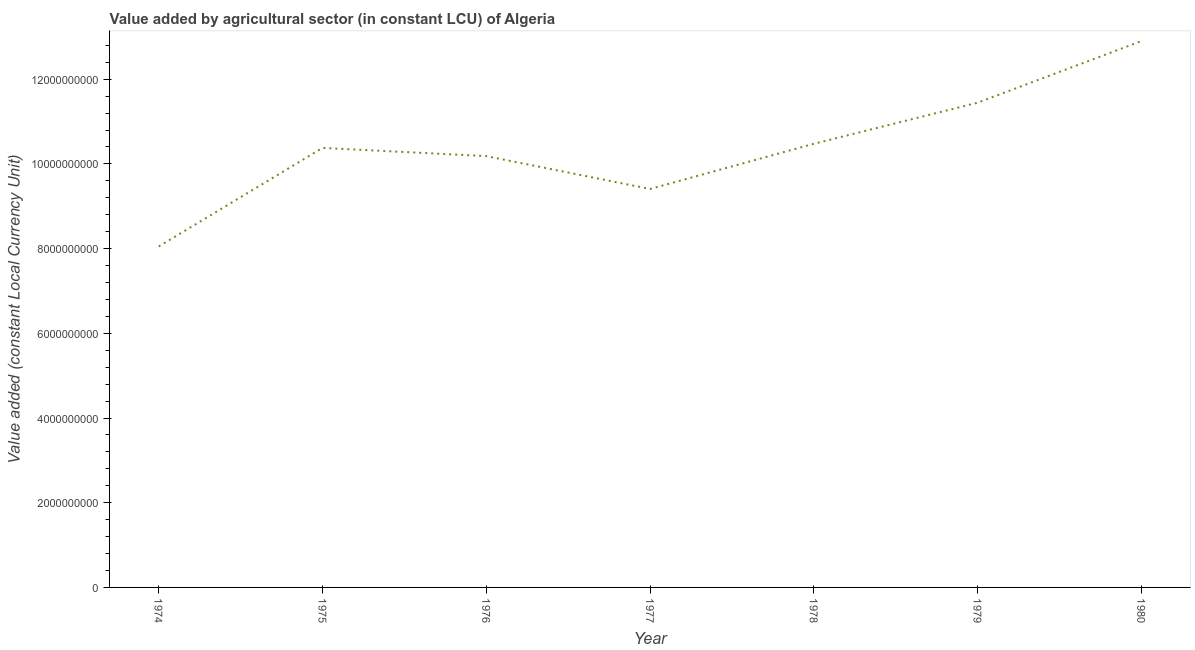What is the value added by agriculture sector in 1977?
Give a very brief answer. 9.41e+09. Across all years, what is the maximum value added by agriculture sector?
Provide a succinct answer. 1.29e+1. Across all years, what is the minimum value added by agriculture sector?
Keep it short and to the point. 8.05e+09. In which year was the value added by agriculture sector minimum?
Ensure brevity in your answer.  1974. What is the sum of the value added by agriculture sector?
Offer a very short reply. 7.28e+1. What is the difference between the value added by agriculture sector in 1976 and 1980?
Provide a short and direct response. -2.72e+09. What is the average value added by agriculture sector per year?
Give a very brief answer. 1.04e+1. What is the median value added by agriculture sector?
Keep it short and to the point. 1.04e+1. In how many years, is the value added by agriculture sector greater than 8400000000 LCU?
Offer a terse response. 6. What is the ratio of the value added by agriculture sector in 1976 to that in 1979?
Keep it short and to the point. 0.89. What is the difference between the highest and the second highest value added by agriculture sector?
Ensure brevity in your answer.  1.45e+09. What is the difference between the highest and the lowest value added by agriculture sector?
Ensure brevity in your answer.  4.85e+09. How many lines are there?
Your response must be concise. 1. What is the difference between two consecutive major ticks on the Y-axis?
Provide a succinct answer. 2.00e+09. Are the values on the major ticks of Y-axis written in scientific E-notation?
Keep it short and to the point. No. Does the graph contain any zero values?
Make the answer very short. No. Does the graph contain grids?
Ensure brevity in your answer.  No. What is the title of the graph?
Provide a succinct answer. Value added by agricultural sector (in constant LCU) of Algeria. What is the label or title of the Y-axis?
Your answer should be very brief. Value added (constant Local Currency Unit). What is the Value added (constant Local Currency Unit) of 1974?
Offer a very short reply. 8.05e+09. What is the Value added (constant Local Currency Unit) in 1975?
Offer a very short reply. 1.04e+1. What is the Value added (constant Local Currency Unit) of 1976?
Offer a terse response. 1.02e+1. What is the Value added (constant Local Currency Unit) of 1977?
Your response must be concise. 9.41e+09. What is the Value added (constant Local Currency Unit) of 1978?
Provide a succinct answer. 1.05e+1. What is the Value added (constant Local Currency Unit) in 1979?
Provide a short and direct response. 1.14e+1. What is the Value added (constant Local Currency Unit) of 1980?
Provide a short and direct response. 1.29e+1. What is the difference between the Value added (constant Local Currency Unit) in 1974 and 1975?
Provide a short and direct response. -2.33e+09. What is the difference between the Value added (constant Local Currency Unit) in 1974 and 1976?
Offer a terse response. -2.13e+09. What is the difference between the Value added (constant Local Currency Unit) in 1974 and 1977?
Ensure brevity in your answer.  -1.36e+09. What is the difference between the Value added (constant Local Currency Unit) in 1974 and 1978?
Offer a very short reply. -2.42e+09. What is the difference between the Value added (constant Local Currency Unit) in 1974 and 1979?
Your answer should be very brief. -3.39e+09. What is the difference between the Value added (constant Local Currency Unit) in 1974 and 1980?
Your response must be concise. -4.85e+09. What is the difference between the Value added (constant Local Currency Unit) in 1975 and 1976?
Make the answer very short. 1.94e+08. What is the difference between the Value added (constant Local Currency Unit) in 1975 and 1977?
Your answer should be very brief. 9.70e+08. What is the difference between the Value added (constant Local Currency Unit) in 1975 and 1978?
Offer a very short reply. -9.70e+07. What is the difference between the Value added (constant Local Currency Unit) in 1975 and 1979?
Offer a terse response. -1.07e+09. What is the difference between the Value added (constant Local Currency Unit) in 1975 and 1980?
Your answer should be compact. -2.52e+09. What is the difference between the Value added (constant Local Currency Unit) in 1976 and 1977?
Offer a terse response. 7.76e+08. What is the difference between the Value added (constant Local Currency Unit) in 1976 and 1978?
Your response must be concise. -2.91e+08. What is the difference between the Value added (constant Local Currency Unit) in 1976 and 1979?
Provide a short and direct response. -1.26e+09. What is the difference between the Value added (constant Local Currency Unit) in 1976 and 1980?
Provide a succinct answer. -2.72e+09. What is the difference between the Value added (constant Local Currency Unit) in 1977 and 1978?
Give a very brief answer. -1.07e+09. What is the difference between the Value added (constant Local Currency Unit) in 1977 and 1979?
Provide a succinct answer. -2.04e+09. What is the difference between the Value added (constant Local Currency Unit) in 1977 and 1980?
Your response must be concise. -3.49e+09. What is the difference between the Value added (constant Local Currency Unit) in 1978 and 1979?
Make the answer very short. -9.70e+08. What is the difference between the Value added (constant Local Currency Unit) in 1978 and 1980?
Keep it short and to the point. -2.42e+09. What is the difference between the Value added (constant Local Currency Unit) in 1979 and 1980?
Keep it short and to the point. -1.45e+09. What is the ratio of the Value added (constant Local Currency Unit) in 1974 to that in 1975?
Ensure brevity in your answer.  0.78. What is the ratio of the Value added (constant Local Currency Unit) in 1974 to that in 1976?
Ensure brevity in your answer.  0.79. What is the ratio of the Value added (constant Local Currency Unit) in 1974 to that in 1977?
Your response must be concise. 0.86. What is the ratio of the Value added (constant Local Currency Unit) in 1974 to that in 1978?
Provide a short and direct response. 0.77. What is the ratio of the Value added (constant Local Currency Unit) in 1974 to that in 1979?
Offer a terse response. 0.7. What is the ratio of the Value added (constant Local Currency Unit) in 1974 to that in 1980?
Offer a very short reply. 0.62. What is the ratio of the Value added (constant Local Currency Unit) in 1975 to that in 1976?
Your answer should be compact. 1.02. What is the ratio of the Value added (constant Local Currency Unit) in 1975 to that in 1977?
Keep it short and to the point. 1.1. What is the ratio of the Value added (constant Local Currency Unit) in 1975 to that in 1979?
Offer a terse response. 0.91. What is the ratio of the Value added (constant Local Currency Unit) in 1975 to that in 1980?
Your response must be concise. 0.81. What is the ratio of the Value added (constant Local Currency Unit) in 1976 to that in 1977?
Provide a succinct answer. 1.08. What is the ratio of the Value added (constant Local Currency Unit) in 1976 to that in 1979?
Your answer should be compact. 0.89. What is the ratio of the Value added (constant Local Currency Unit) in 1976 to that in 1980?
Offer a terse response. 0.79. What is the ratio of the Value added (constant Local Currency Unit) in 1977 to that in 1978?
Your answer should be compact. 0.9. What is the ratio of the Value added (constant Local Currency Unit) in 1977 to that in 1979?
Ensure brevity in your answer.  0.82. What is the ratio of the Value added (constant Local Currency Unit) in 1977 to that in 1980?
Your response must be concise. 0.73. What is the ratio of the Value added (constant Local Currency Unit) in 1978 to that in 1979?
Offer a very short reply. 0.92. What is the ratio of the Value added (constant Local Currency Unit) in 1978 to that in 1980?
Make the answer very short. 0.81. What is the ratio of the Value added (constant Local Currency Unit) in 1979 to that in 1980?
Ensure brevity in your answer.  0.89. 